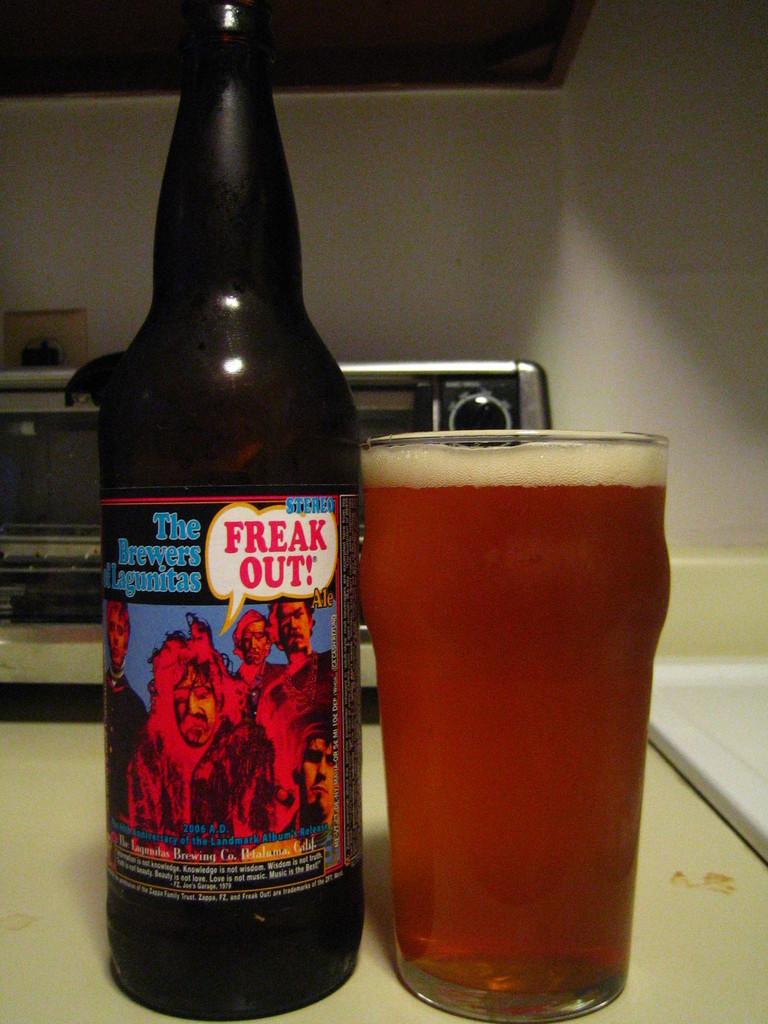What is in the bottle?
Your answer should be compact. Beer. 